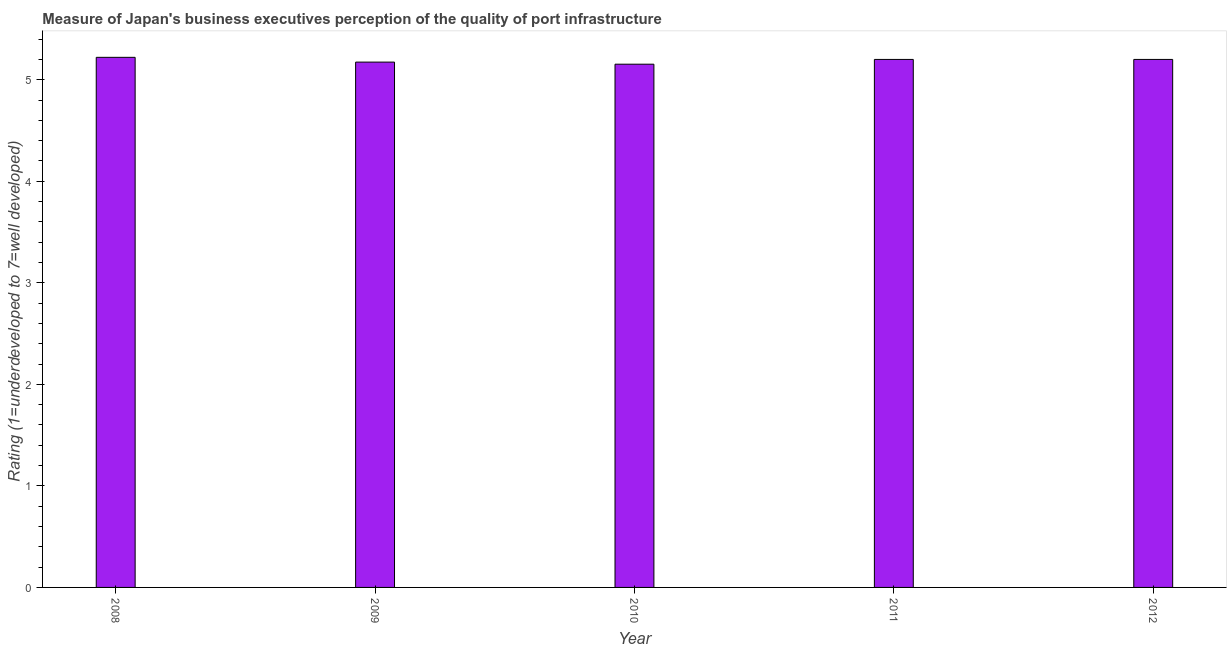Does the graph contain any zero values?
Your response must be concise. No. What is the title of the graph?
Provide a succinct answer. Measure of Japan's business executives perception of the quality of port infrastructure. What is the label or title of the Y-axis?
Provide a succinct answer. Rating (1=underdeveloped to 7=well developed) . What is the rating measuring quality of port infrastructure in 2009?
Give a very brief answer. 5.17. Across all years, what is the maximum rating measuring quality of port infrastructure?
Give a very brief answer. 5.22. Across all years, what is the minimum rating measuring quality of port infrastructure?
Offer a terse response. 5.15. In which year was the rating measuring quality of port infrastructure minimum?
Provide a succinct answer. 2010. What is the sum of the rating measuring quality of port infrastructure?
Give a very brief answer. 25.95. What is the difference between the rating measuring quality of port infrastructure in 2009 and 2011?
Your answer should be compact. -0.03. What is the average rating measuring quality of port infrastructure per year?
Your response must be concise. 5.19. What is the median rating measuring quality of port infrastructure?
Provide a succinct answer. 5.2. What is the ratio of the rating measuring quality of port infrastructure in 2009 to that in 2012?
Keep it short and to the point. 0.99. What is the difference between the highest and the second highest rating measuring quality of port infrastructure?
Offer a terse response. 0.02. What is the difference between the highest and the lowest rating measuring quality of port infrastructure?
Keep it short and to the point. 0.07. In how many years, is the rating measuring quality of port infrastructure greater than the average rating measuring quality of port infrastructure taken over all years?
Keep it short and to the point. 3. How many bars are there?
Provide a succinct answer. 5. Are all the bars in the graph horizontal?
Your answer should be compact. No. What is the difference between two consecutive major ticks on the Y-axis?
Provide a short and direct response. 1. Are the values on the major ticks of Y-axis written in scientific E-notation?
Your response must be concise. No. What is the Rating (1=underdeveloped to 7=well developed)  of 2008?
Ensure brevity in your answer.  5.22. What is the Rating (1=underdeveloped to 7=well developed)  in 2009?
Give a very brief answer. 5.17. What is the Rating (1=underdeveloped to 7=well developed)  of 2010?
Offer a very short reply. 5.15. What is the Rating (1=underdeveloped to 7=well developed)  in 2011?
Provide a succinct answer. 5.2. What is the Rating (1=underdeveloped to 7=well developed)  in 2012?
Make the answer very short. 5.2. What is the difference between the Rating (1=underdeveloped to 7=well developed)  in 2008 and 2009?
Your response must be concise. 0.05. What is the difference between the Rating (1=underdeveloped to 7=well developed)  in 2008 and 2010?
Provide a succinct answer. 0.07. What is the difference between the Rating (1=underdeveloped to 7=well developed)  in 2008 and 2011?
Provide a succinct answer. 0.02. What is the difference between the Rating (1=underdeveloped to 7=well developed)  in 2008 and 2012?
Offer a very short reply. 0.02. What is the difference between the Rating (1=underdeveloped to 7=well developed)  in 2009 and 2010?
Offer a terse response. 0.02. What is the difference between the Rating (1=underdeveloped to 7=well developed)  in 2009 and 2011?
Ensure brevity in your answer.  -0.03. What is the difference between the Rating (1=underdeveloped to 7=well developed)  in 2009 and 2012?
Ensure brevity in your answer.  -0.03. What is the difference between the Rating (1=underdeveloped to 7=well developed)  in 2010 and 2011?
Provide a short and direct response. -0.05. What is the difference between the Rating (1=underdeveloped to 7=well developed)  in 2010 and 2012?
Provide a short and direct response. -0.05. What is the difference between the Rating (1=underdeveloped to 7=well developed)  in 2011 and 2012?
Offer a very short reply. 0. What is the ratio of the Rating (1=underdeveloped to 7=well developed)  in 2008 to that in 2011?
Your answer should be very brief. 1. What is the ratio of the Rating (1=underdeveloped to 7=well developed)  in 2008 to that in 2012?
Offer a very short reply. 1. What is the ratio of the Rating (1=underdeveloped to 7=well developed)  in 2009 to that in 2012?
Provide a succinct answer. 0.99. What is the ratio of the Rating (1=underdeveloped to 7=well developed)  in 2011 to that in 2012?
Keep it short and to the point. 1. 